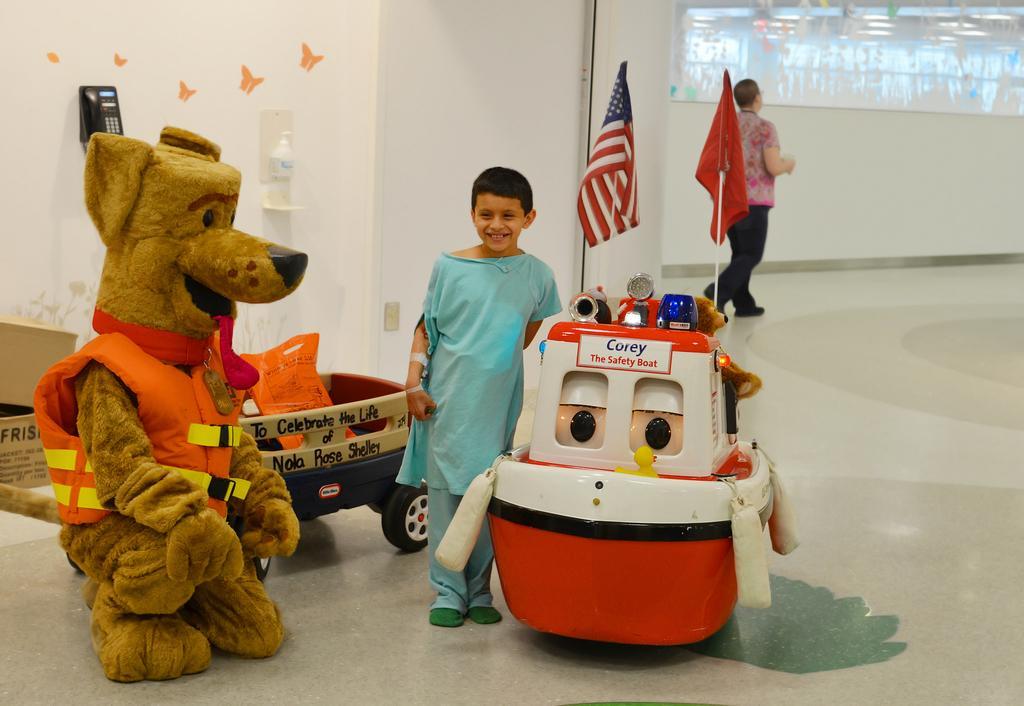Please provide a concise description of this image. The girl in blue dress is standing beside the toy vehicles and she is smiling. Beside that, we see a stuffed toy and behind her, we see flags which are in red, blue and white color. Behind that, we see a white wall on which landline mobile is placed. Beside that, we see the woman in the pink shirt is walking. 